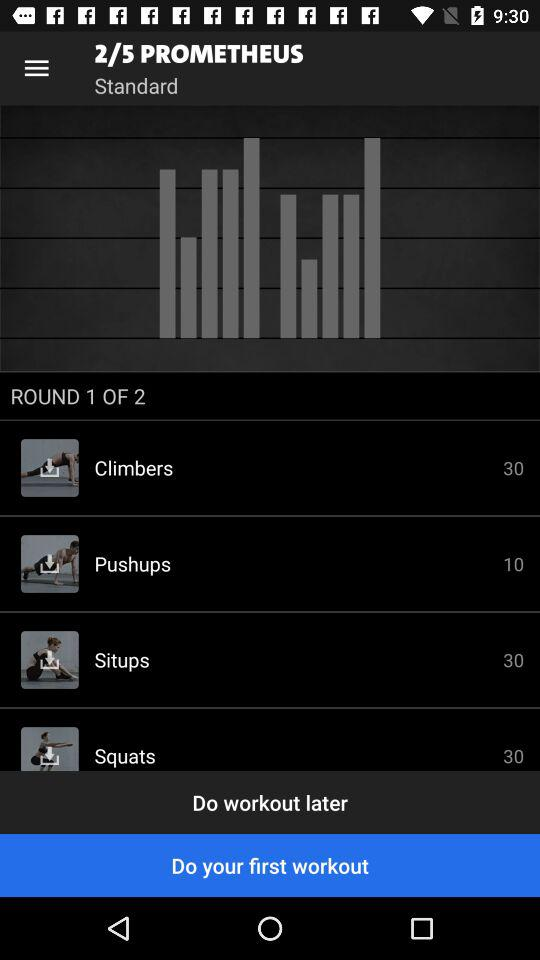Which round of "PROMETHEUS" is the person currently on? The person is currently on round 2 of "PROMETHEUS". 